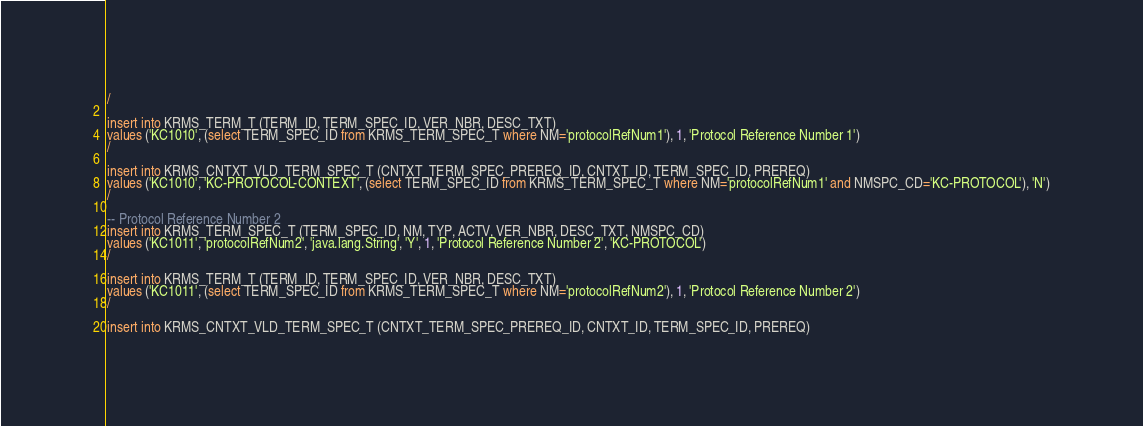Convert code to text. <code><loc_0><loc_0><loc_500><loc_500><_SQL_>/

insert into KRMS_TERM_T (TERM_ID, TERM_SPEC_ID, VER_NBR, DESC_TXT)
values ('KC1010', (select TERM_SPEC_ID from KRMS_TERM_SPEC_T where NM='protocolRefNum1'), 1, 'Protocol Reference Number 1')
/

insert into KRMS_CNTXT_VLD_TERM_SPEC_T (CNTXT_TERM_SPEC_PREREQ_ID, CNTXT_ID, TERM_SPEC_ID, PREREQ)
values ('KC1010', 'KC-PROTOCOL-CONTEXT', (select TERM_SPEC_ID from KRMS_TERM_SPEC_T where NM='protocolRefNum1' and NMSPC_CD='KC-PROTOCOL'), 'N')
/

-- Protocol Reference Number 2
insert into KRMS_TERM_SPEC_T (TERM_SPEC_ID, NM, TYP, ACTV, VER_NBR, DESC_TXT, NMSPC_CD)
values ('KC1011', 'protocolRefNum2', 'java.lang.String', 'Y', 1, 'Protocol Reference Number 2', 'KC-PROTOCOL')
/

insert into KRMS_TERM_T (TERM_ID, TERM_SPEC_ID, VER_NBR, DESC_TXT)
values ('KC1011', (select TERM_SPEC_ID from KRMS_TERM_SPEC_T where NM='protocolRefNum2'), 1, 'Protocol Reference Number 2')
/

insert into KRMS_CNTXT_VLD_TERM_SPEC_T (CNTXT_TERM_SPEC_PREREQ_ID, CNTXT_ID, TERM_SPEC_ID, PREREQ)</code> 